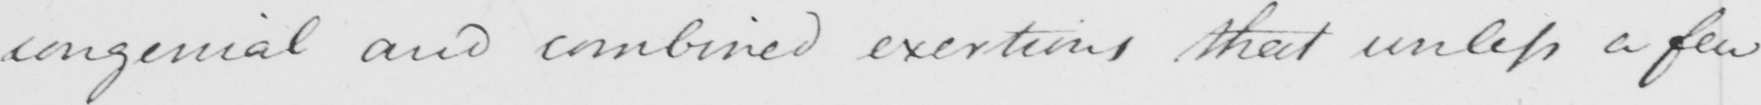What text is written in this handwritten line? congenial and combined exertions that unless a few 